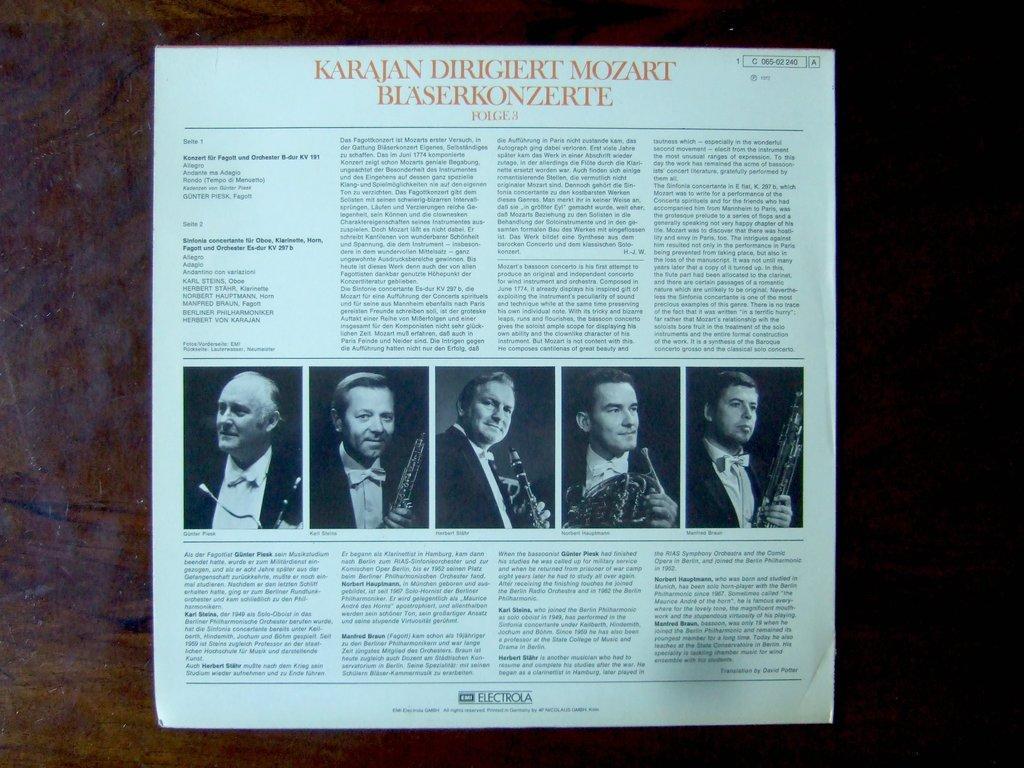Please provide a concise description of this image. In the center of the image we can see a magazine. On magazine we can see some photos and text are present. 